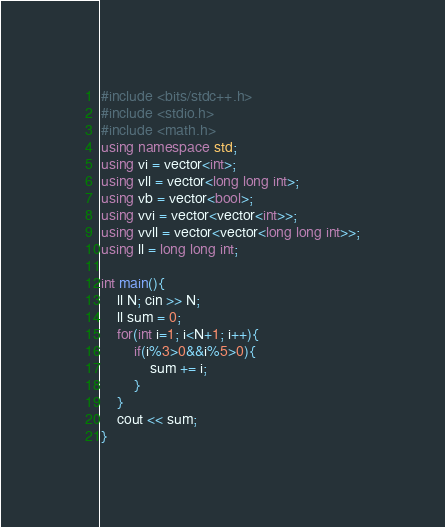<code> <loc_0><loc_0><loc_500><loc_500><_C++_>#include <bits/stdc++.h>
#include <stdio.h>
#include <math.h>
using namespace std;
using vi = vector<int>;
using vll = vector<long long int>;
using vb = vector<bool>;
using vvi = vector<vector<int>>;
using vvll = vector<vector<long long int>>;
using ll = long long int;

int main(){
    ll N; cin >> N;
    ll sum = 0;
    for(int i=1; i<N+1; i++){
        if(i%3>0&&i%5>0){
            sum += i;
        }
    }
    cout << sum;
}</code> 